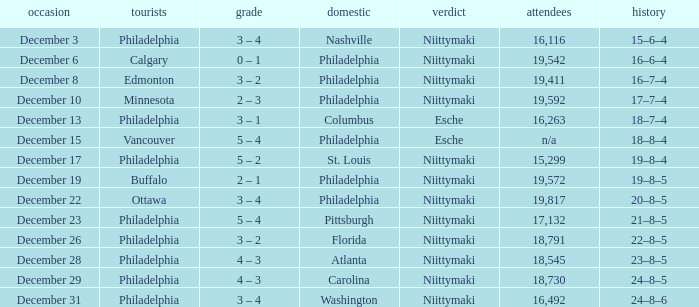What was the decision when the attendance was 19,592? Niittymaki. 